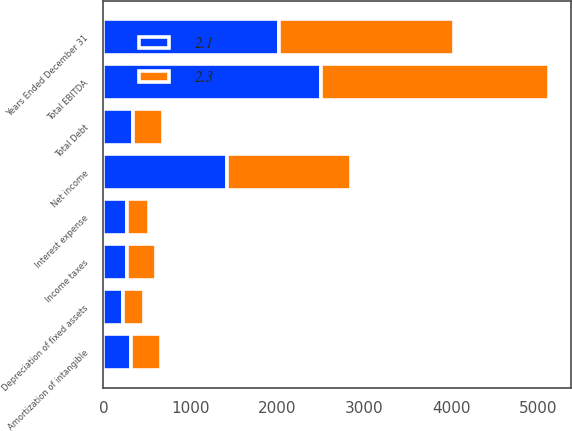<chart> <loc_0><loc_0><loc_500><loc_500><stacked_bar_chart><ecel><fcel>Years Ended December 31<fcel>Net income<fcel>Interest expense<fcel>Income taxes<fcel>Depreciation of fixed assets<fcel>Amortization of intangible<fcel>Total EBITDA<fcel>Total Debt<nl><fcel>2.1<fcel>2015<fcel>1422<fcel>273<fcel>267<fcel>229<fcel>314<fcel>2505<fcel>343<nl><fcel>2.3<fcel>2014<fcel>1431<fcel>255<fcel>334<fcel>242<fcel>352<fcel>2614<fcel>343<nl></chart> 